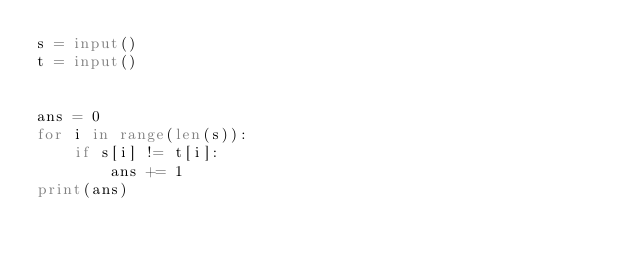Convert code to text. <code><loc_0><loc_0><loc_500><loc_500><_Python_>s = input()
t = input()


ans = 0
for i in range(len(s)):
    if s[i] != t[i]:
        ans += 1
print(ans)
</code> 